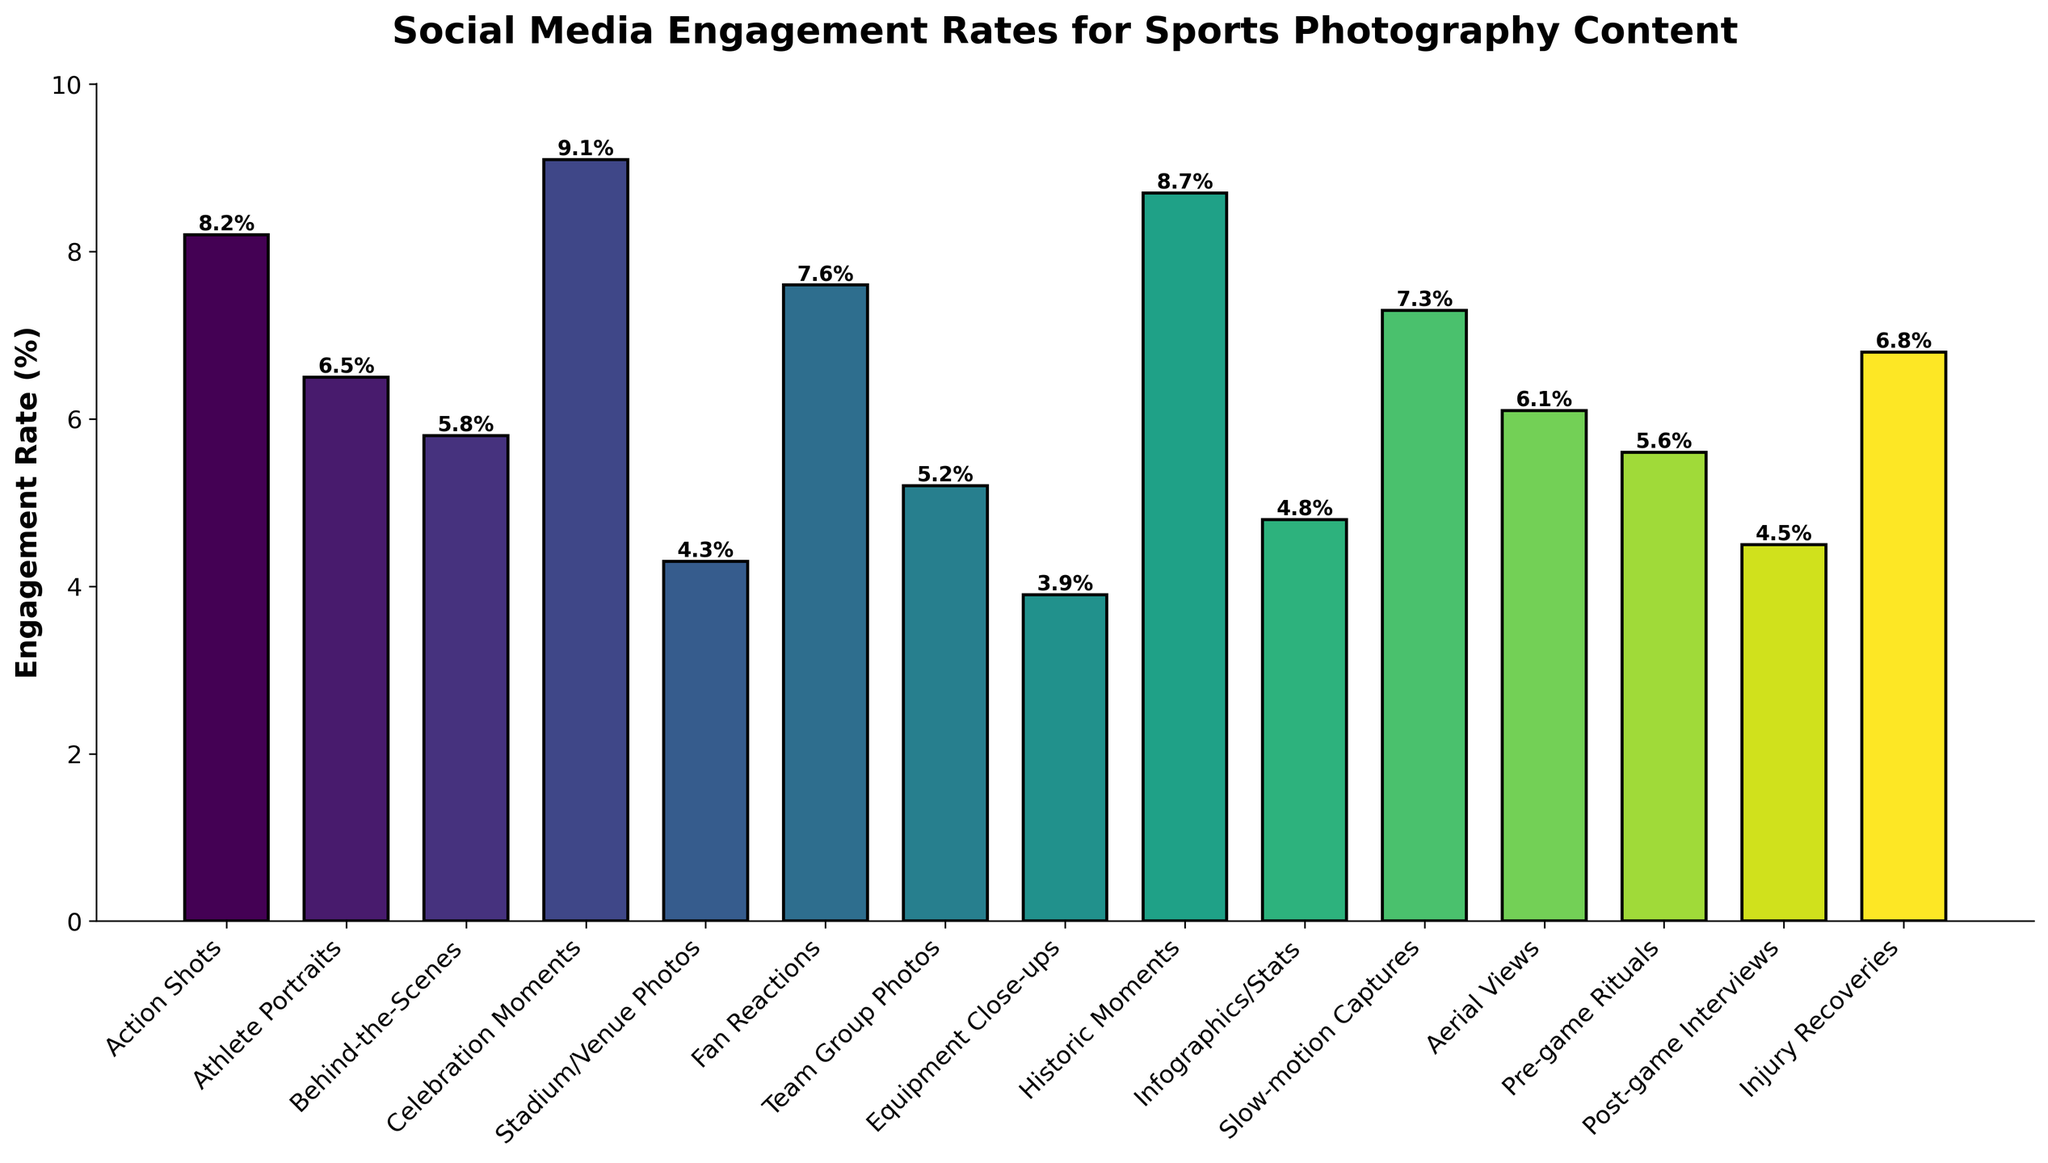Which type of sports photography content has the highest engagement rate? Look for the tallest bar in the chart. The tallest bar is labeled "Celebration Moments" with an engagement rate of 9.1%.
Answer: Celebration Moments Which type of sports photography content has the lowest engagement rate? Look for the shortest bar in the chart. The shortest bar is labeled "Equipment Close-ups" with an engagement rate of 3.9%.
Answer: Equipment Close-ups How does the engagement rate of "Athlete Portraits" compare to "Fan Reactions"? Check the height of the bars for "Athlete Portraits" and "Fan Reactions". "Athlete Portraits" has an engagement rate of 6.5% and "Fan Reactions" has an engagement rate of 7.6%. "Fan Reactions" is higher.
Answer: Fan Reactions is higher What is the average engagement rate for "Pre-game Rituals", "Post-game Interviews", and "Injury Recoveries"? Add the engagement rates of the three categories and divide by 3. (5.6% + 4.5% + 6.8%) / 3 = 16.9% / 3 = 5.63%.
Answer: 5.63% Which types of sports photography content have engagement rates higher than 7%? Identify the bars with heights greater than 7%. "Action Shots" (8.2%), "Celebration Moments" (9.1%), "Historic Moments" (8.7%), and "Fan Reactions" (7.6%), "Slow-motion Captures" (7.3%).
Answer: Action Shots, Celebration Moments, Historic Moments, Fan Reactions, Slow-motion Captures What is the difference in engagement rate between "Historic Moments" and "Stadium/Venue Photos"? Subtract the engagement rate of "Stadium/Venue Photos" from "Historic Moments". 8.7% - 4.3% = 4.4%.
Answer: 4.4% How does the engagement rate of "Behind-the-Scenes" compare to "Aerial Views"? Check the height of the bars for "Behind-the-Scenes" and "Aerial Views". "Behind-the-Scenes" has an engagement rate of 5.8% and "Aerial Views" has an engagement rate of 6.1%. "Aerial Views" is higher.
Answer: Aerial Views is higher What is the combined engagement rate for "Action Shots" and "Celebration Moments"? Add the engagement rates of the two categories. 8.2% + 9.1% = 17.3%.
Answer: 17.3% Is the engagement rate for "Infographics/Stats" greater than or less than "Team Group Photos"? Compare the height of the bars for "Infographics/Stats" and "Team Group Photos". "Infographics/Stats" is 4.8% and "Team Group Photos" is 5.2%. "Infographics/Stats" is less than "Team Group Photos".
Answer: less How much higher is the engagement rate for "Athlete Portraits" compared to "Equipment Close-ups"? Subtract the engagement rate of "Equipment Close-ups" from "Athlete Portraits". 6.5% - 3.9% = 2.6%.
Answer: 2.6% 